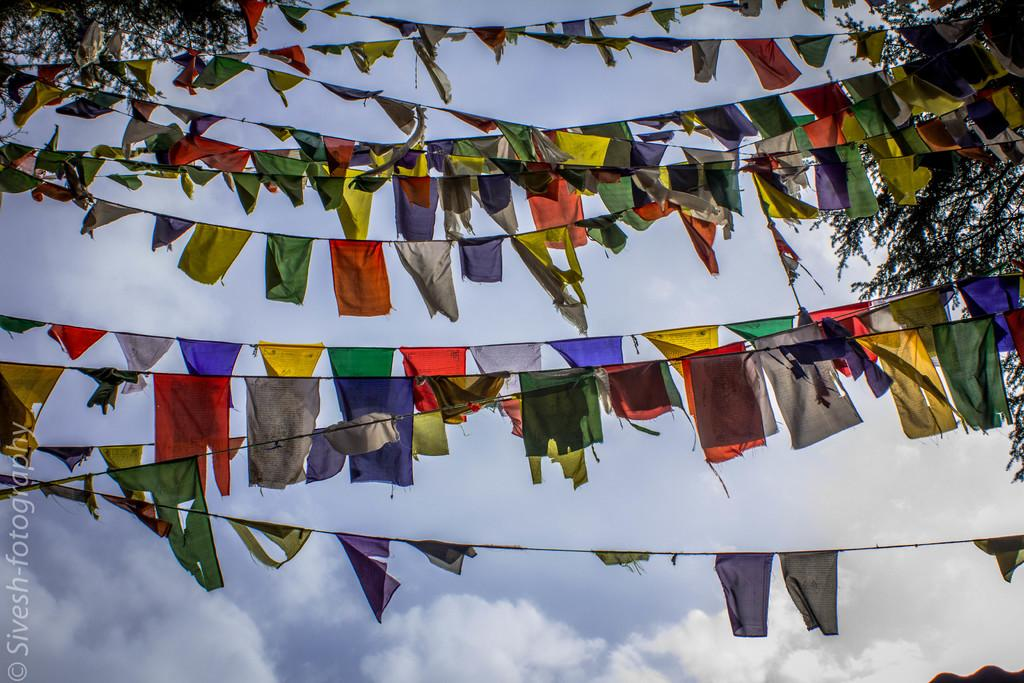What is present in the image that can be worn? There are clothes in the image that can be worn. How many different colors can be seen in the clothes? The clothes are in different colors. How are the clothes arranged in the image? The clothes are tied to a rope. What can be seen in the background of the image? There are trees on either side of the rope. What actor is seen rubbing the clothes in the image? There is no actor present in the image, and the clothes are tied to a rope, not being rubbed. 